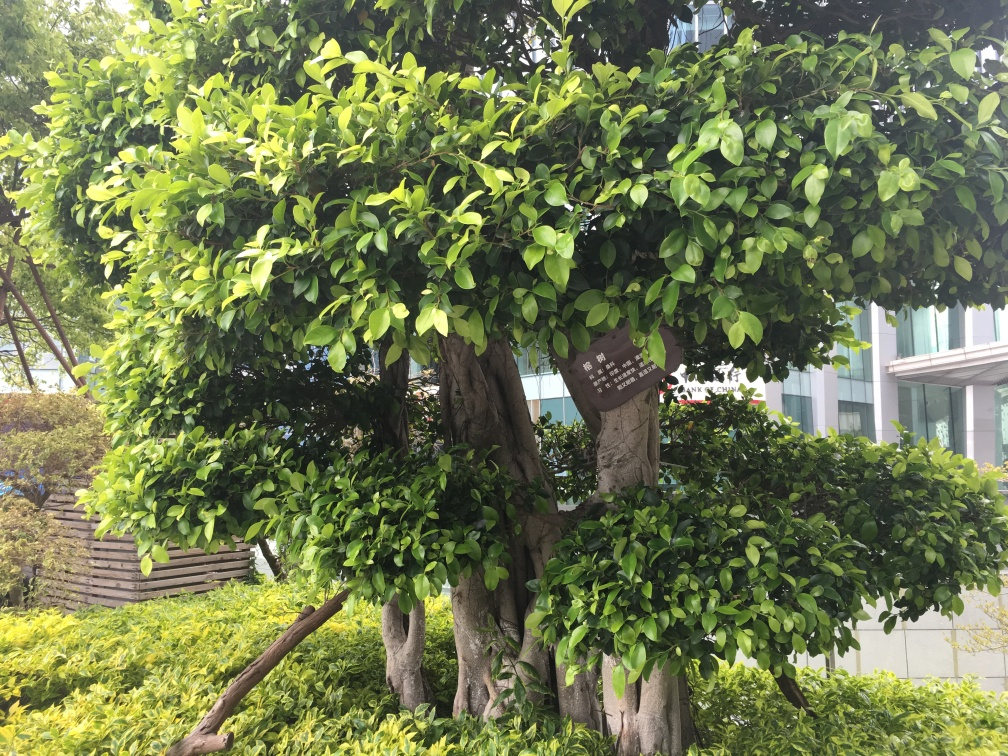What does the sign attached to the tree say? The image resolution and angle do not allow for the text on the sign to be read clearly, but it appears to be an informational sign, likely offering details about the tree or area, such as the species of the tree, a memorial dedication, or guidelines for preservation. 